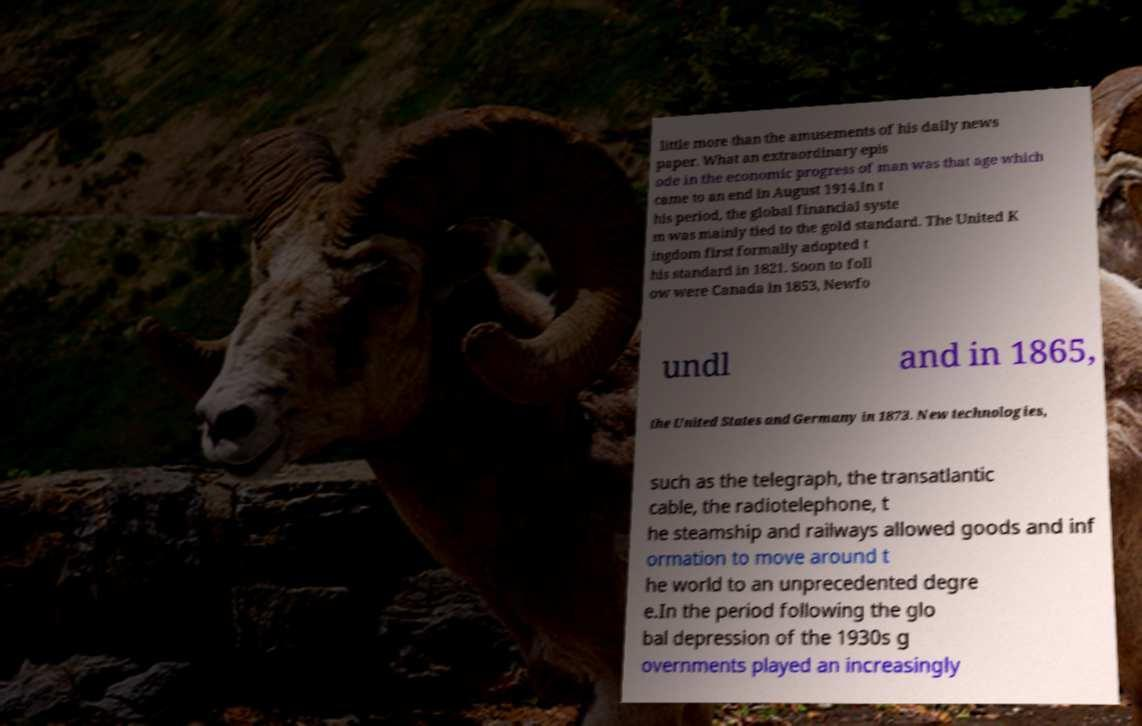Can you accurately transcribe the text from the provided image for me? little more than the amusements of his daily news paper. What an extraordinary epis ode in the economic progress of man was that age which came to an end in August 1914.In t his period, the global financial syste m was mainly tied to the gold standard. The United K ingdom first formally adopted t his standard in 1821. Soon to foll ow were Canada in 1853, Newfo undl and in 1865, the United States and Germany in 1873. New technologies, such as the telegraph, the transatlantic cable, the radiotelephone, t he steamship and railways allowed goods and inf ormation to move around t he world to an unprecedented degre e.In the period following the glo bal depression of the 1930s g overnments played an increasingly 